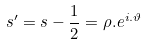<formula> <loc_0><loc_0><loc_500><loc_500>s ^ { \prime } = s - \frac { 1 } { 2 } = \rho . e ^ { i . \vartheta }</formula> 